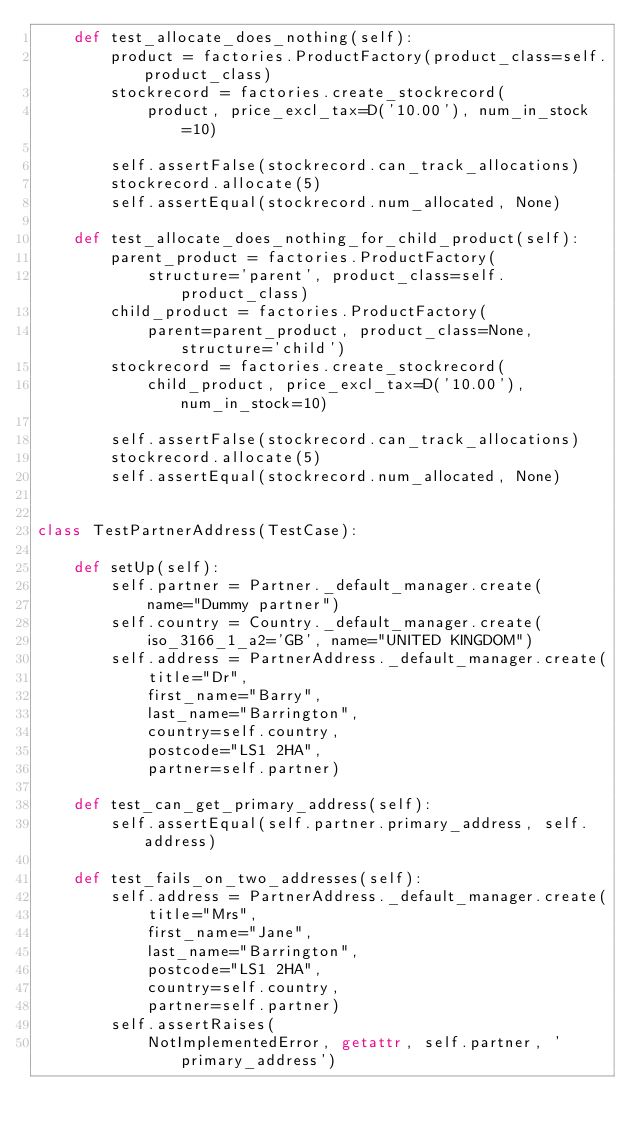Convert code to text. <code><loc_0><loc_0><loc_500><loc_500><_Python_>    def test_allocate_does_nothing(self):
        product = factories.ProductFactory(product_class=self.product_class)
        stockrecord = factories.create_stockrecord(
            product, price_excl_tax=D('10.00'), num_in_stock=10)

        self.assertFalse(stockrecord.can_track_allocations)
        stockrecord.allocate(5)
        self.assertEqual(stockrecord.num_allocated, None)

    def test_allocate_does_nothing_for_child_product(self):
        parent_product = factories.ProductFactory(
            structure='parent', product_class=self.product_class)
        child_product = factories.ProductFactory(
            parent=parent_product, product_class=None, structure='child')
        stockrecord = factories.create_stockrecord(
            child_product, price_excl_tax=D('10.00'), num_in_stock=10)

        self.assertFalse(stockrecord.can_track_allocations)
        stockrecord.allocate(5)
        self.assertEqual(stockrecord.num_allocated, None)


class TestPartnerAddress(TestCase):

    def setUp(self):
        self.partner = Partner._default_manager.create(
            name="Dummy partner")
        self.country = Country._default_manager.create(
            iso_3166_1_a2='GB', name="UNITED KINGDOM")
        self.address = PartnerAddress._default_manager.create(
            title="Dr",
            first_name="Barry",
            last_name="Barrington",
            country=self.country,
            postcode="LS1 2HA",
            partner=self.partner)

    def test_can_get_primary_address(self):
        self.assertEqual(self.partner.primary_address, self.address)

    def test_fails_on_two_addresses(self):
        self.address = PartnerAddress._default_manager.create(
            title="Mrs",
            first_name="Jane",
            last_name="Barrington",
            postcode="LS1 2HA",
            country=self.country,
            partner=self.partner)
        self.assertRaises(
            NotImplementedError, getattr, self.partner, 'primary_address')
</code> 